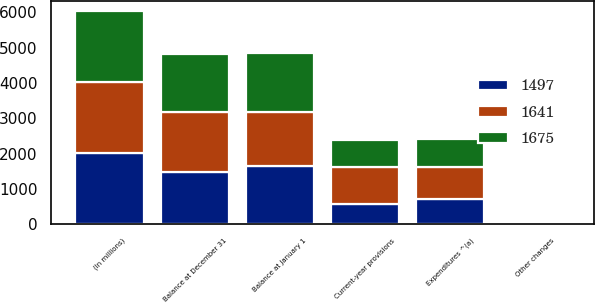Convert chart. <chart><loc_0><loc_0><loc_500><loc_500><stacked_bar_chart><ecel><fcel>(In millions)<fcel>Balance at January 1<fcel>Current-year provisions<fcel>Expenditures ^(a)<fcel>Other changes<fcel>Balance at December 31<nl><fcel>1497<fcel>2010<fcel>1641<fcel>583<fcel>710<fcel>17<fcel>1497<nl><fcel>1675<fcel>2009<fcel>1675<fcel>780<fcel>794<fcel>20<fcel>1641<nl><fcel>1641<fcel>2008<fcel>1541<fcel>1038<fcel>917<fcel>13<fcel>1675<nl></chart> 